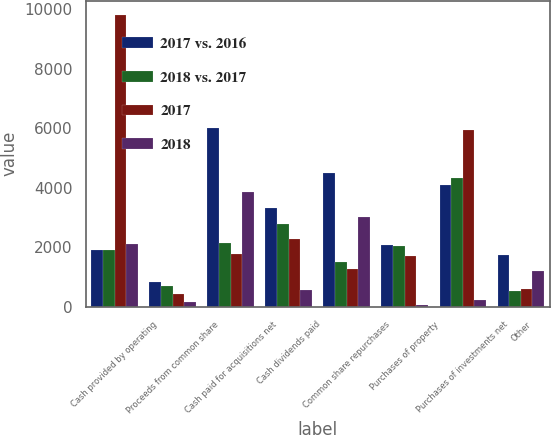<chart> <loc_0><loc_0><loc_500><loc_500><stacked_bar_chart><ecel><fcel>Cash provided by operating<fcel>Proceeds from common share<fcel>Cash paid for acquisitions net<fcel>Cash dividends paid<fcel>Common share repurchases<fcel>Purchases of property<fcel>Purchases of investments net<fcel>Other<nl><fcel>2017 vs. 2016<fcel>1891.5<fcel>838<fcel>5997<fcel>3320<fcel>4500<fcel>2063<fcel>4099<fcel>1743<nl><fcel>2018 vs. 2017<fcel>1891.5<fcel>688<fcel>2131<fcel>2773<fcel>1500<fcel>2023<fcel>4319<fcel>539<nl><fcel>2017<fcel>9795<fcel>429<fcel>1760<fcel>2261<fcel>1280<fcel>1705<fcel>5927<fcel>581<nl><fcel>2018<fcel>2117<fcel>150<fcel>3866<fcel>547<fcel>3000<fcel>40<fcel>220<fcel>1204<nl></chart> 